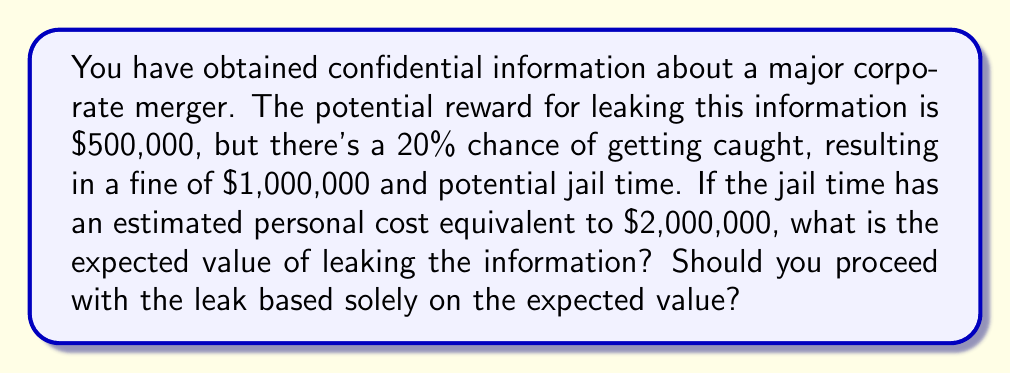Give your solution to this math problem. To solve this problem, we need to calculate the expected value of leaking the information. The expected value is the sum of each possible outcome multiplied by its probability.

Let's break down the scenarios:

1. Success scenario (80% probability):
   Reward = $500,000
   Expected value of success: $500,000 * 0.80 = $400,000

2. Failure scenario (20% probability):
   Cost = Fine + Personal cost of jail time
   Cost = $1,000,000 + $2,000,000 = $3,000,000
   Expected value of failure: -$3,000,000 * 0.20 = -$600,000

Now, let's calculate the total expected value:

$$ E = (500,000 * 0.80) + (-3,000,000 * 0.20) $$
$$ E = 400,000 - 600,000 $$
$$ E = -200,000 $$

The expected value is negative, which means that on average, you would lose $200,000 by leaking the information.

To determine whether to proceed with the leak based solely on the expected value, we compare it to zero:

$$ -200,000 < 0 $$

Since the expected value is less than zero, based solely on this calculation, you should not proceed with the leak.

It's important to note that this analysis only considers the financial and estimated personal costs. In reality, ethical considerations and other factors should also play a crucial role in such decisions.
Answer: The expected value of leaking the information is -$200,000. Based solely on the expected value, you should not proceed with the leak. 